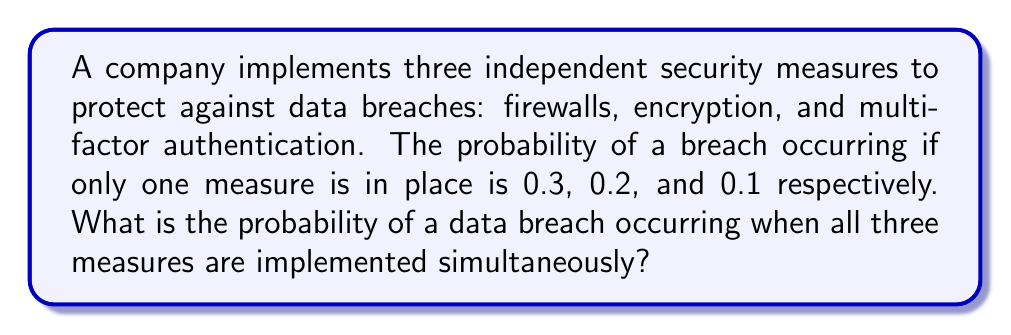Can you answer this question? Let's approach this step-by-step:

1) First, we need to understand that we're looking for the probability of a breach occurring despite all three measures being in place. This is equivalent to the complement of all measures succeeding.

2) Let's define our events:
   $F$ = Firewall succeeds
   $E$ = Encryption succeeds
   $M$ = Multi-factor authentication succeeds

3) We're given the probabilities of failure for each measure:
   $P(\text{not }F) = 0.3$, so $P(F) = 1 - 0.3 = 0.7$
   $P(\text{not }E) = 0.2$, so $P(E) = 1 - 0.2 = 0.8$
   $P(\text{not }M) = 0.1$, so $P(M) = 1 - 0.1 = 0.9$

4) The probability of all measures succeeding is the product of their individual probabilities of success (since they're independent):

   $P(F \text{ and } E \text{ and } M) = P(F) \times P(E) \times P(M)$

5) Let's calculate this:
   $P(F \text{ and } E \text{ and } M) = 0.7 \times 0.8 \times 0.9 = 0.504$

6) The probability of a breach is the complement of this probability:

   $P(\text{breach}) = 1 - P(F \text{ and } E \text{ and } M) = 1 - 0.504 = 0.496$

Therefore, the probability of a data breach occurring when all three measures are implemented is 0.496 or 49.6%.
Answer: 0.496 